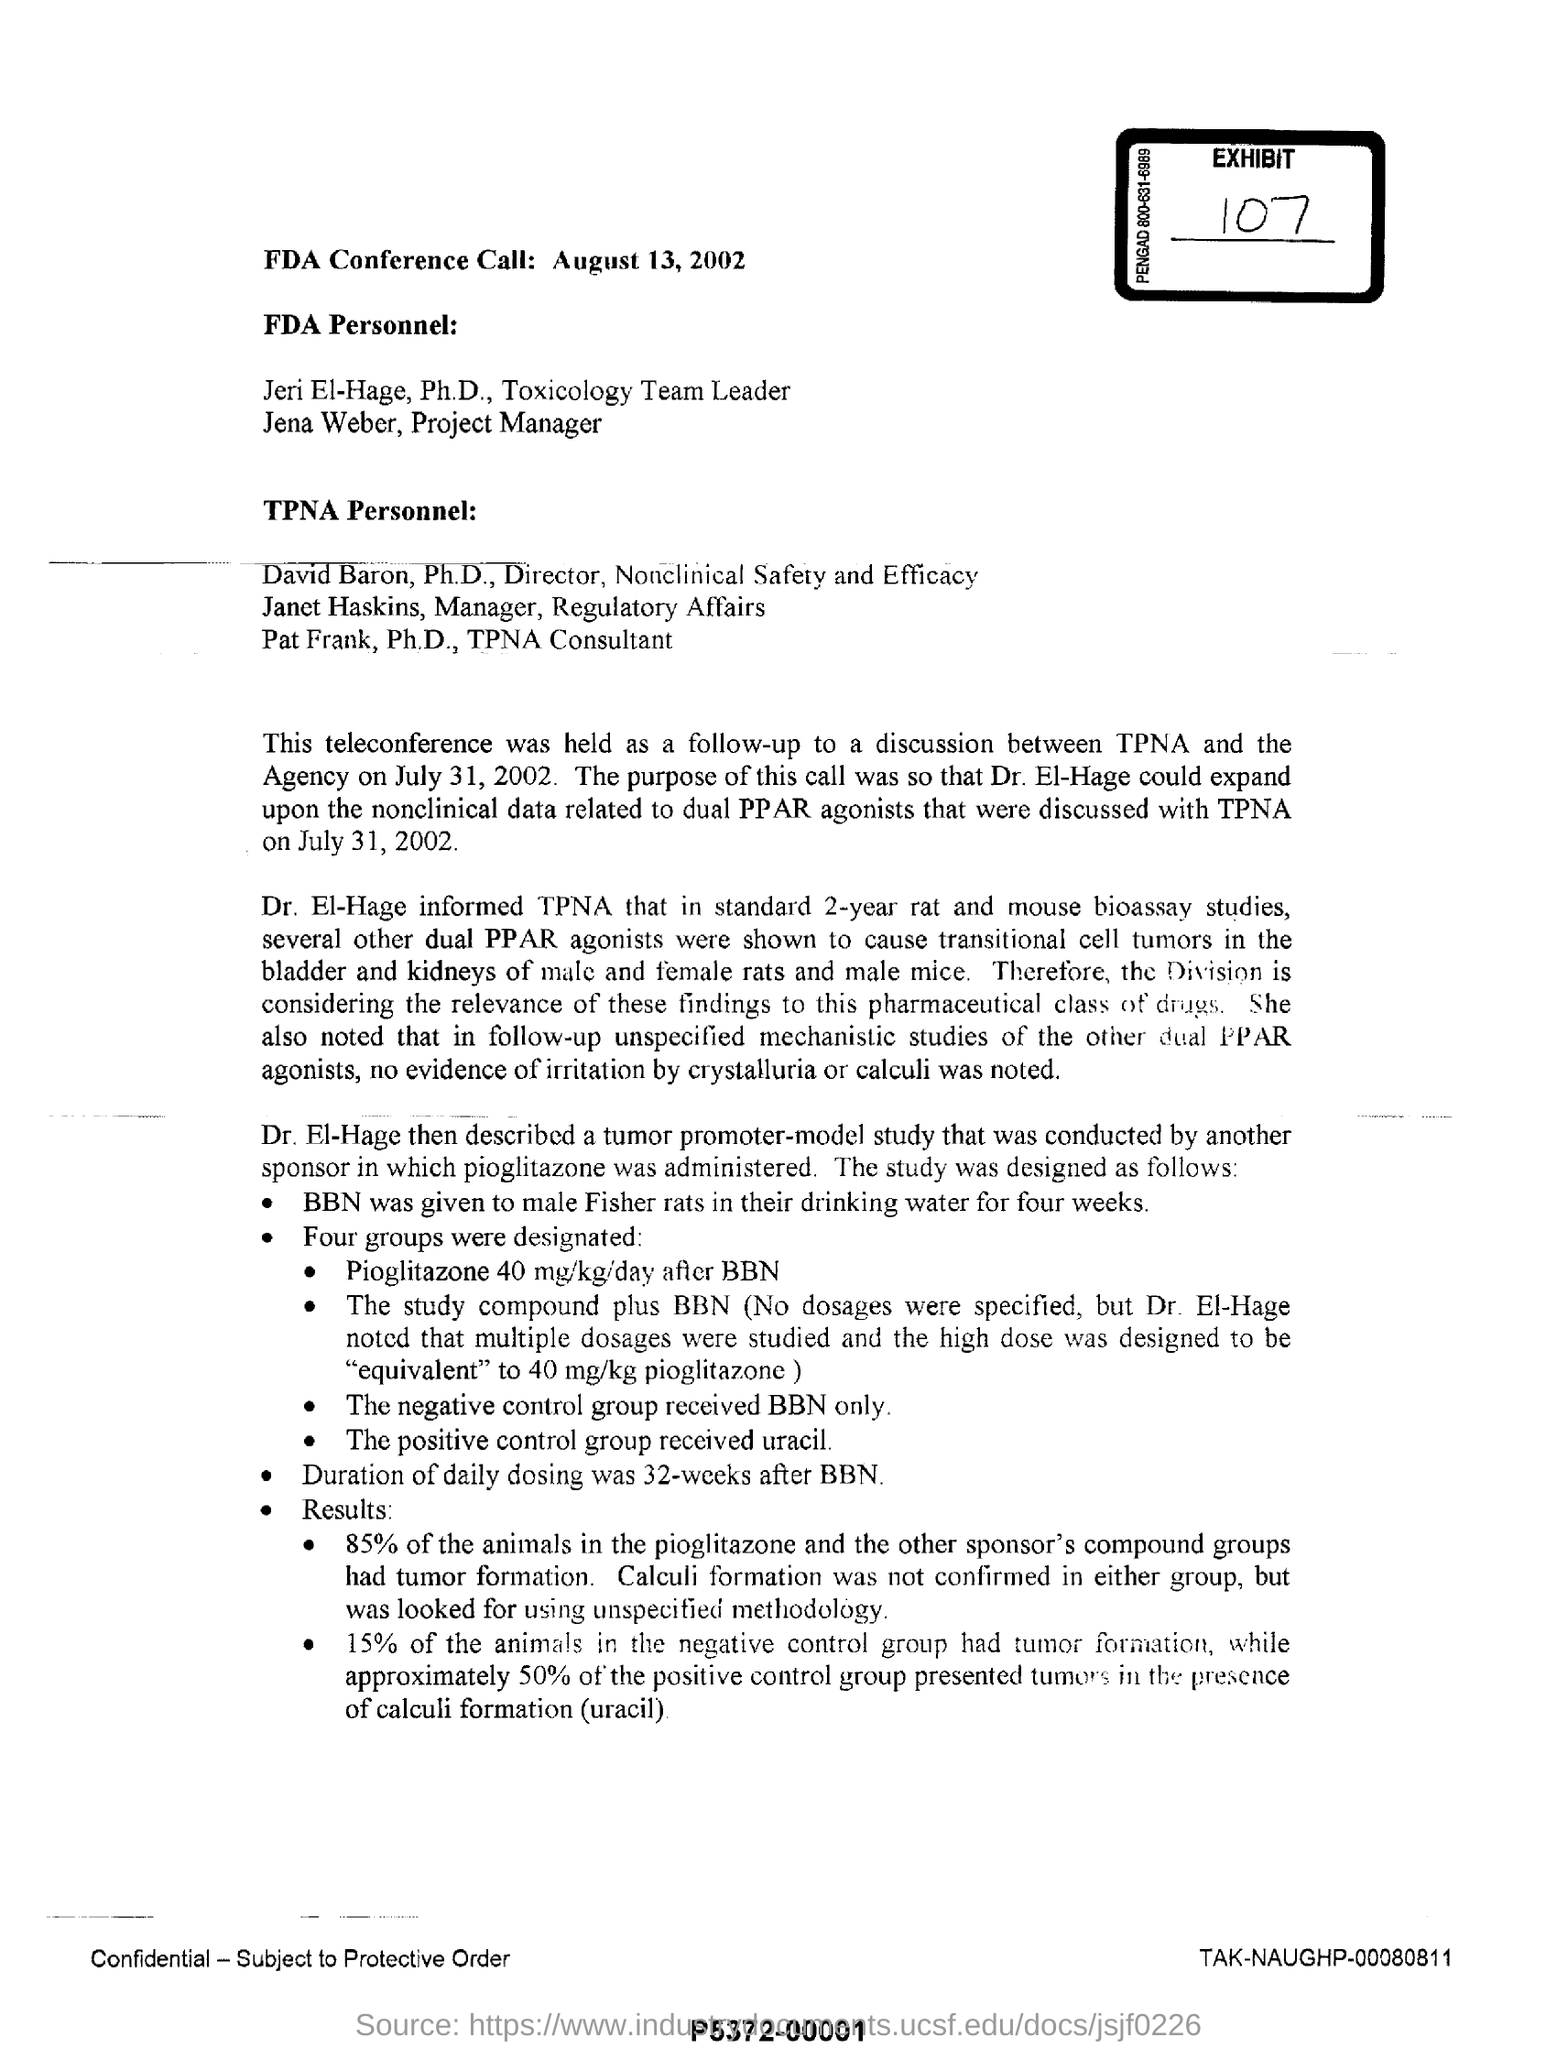What are the key results of the pioglitazone study mentioned? In the pioglitazone study, 85% of the animals demonstrated tumor formation, which was a significant finding discussed in the document. And what about the results from the control groups? The negative control group, which received just BBN, had 15% of its members develop tumors, while about 50% of the positive control group, treated with uracil, showed calculi formation. 